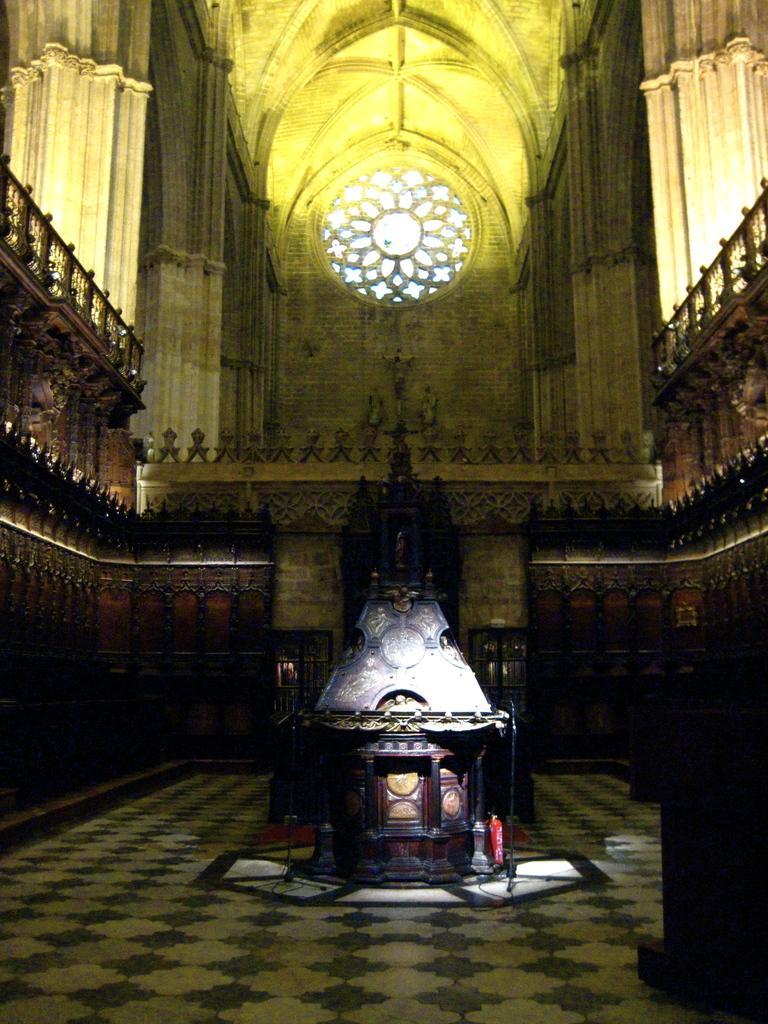Please provide a concise description of this image. This picture is clicked inside. In the center there is a wooden object placed on the ground. On the right and on the left we can see the deck rails. At the top there is an arch and we can see the window and the pillars. 